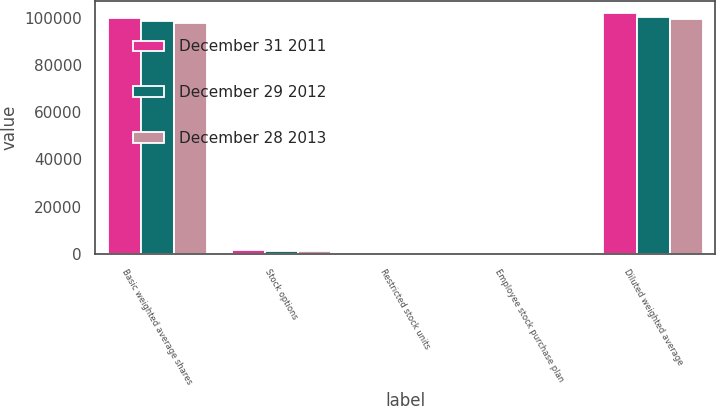Convert chart. <chart><loc_0><loc_0><loc_500><loc_500><stacked_bar_chart><ecel><fcel>Basic weighted average shares<fcel>Stock options<fcel>Restricted stock units<fcel>Employee stock purchase plan<fcel>Diluted weighted average<nl><fcel>December 31 2011<fcel>99859<fcel>1536<fcel>427<fcel>1<fcel>101823<nl><fcel>December 29 2012<fcel>98709<fcel>1245<fcel>314<fcel>1<fcel>100269<nl><fcel>December 28 2013<fcel>97710<fcel>1163<fcel>376<fcel>2<fcel>99251<nl></chart> 